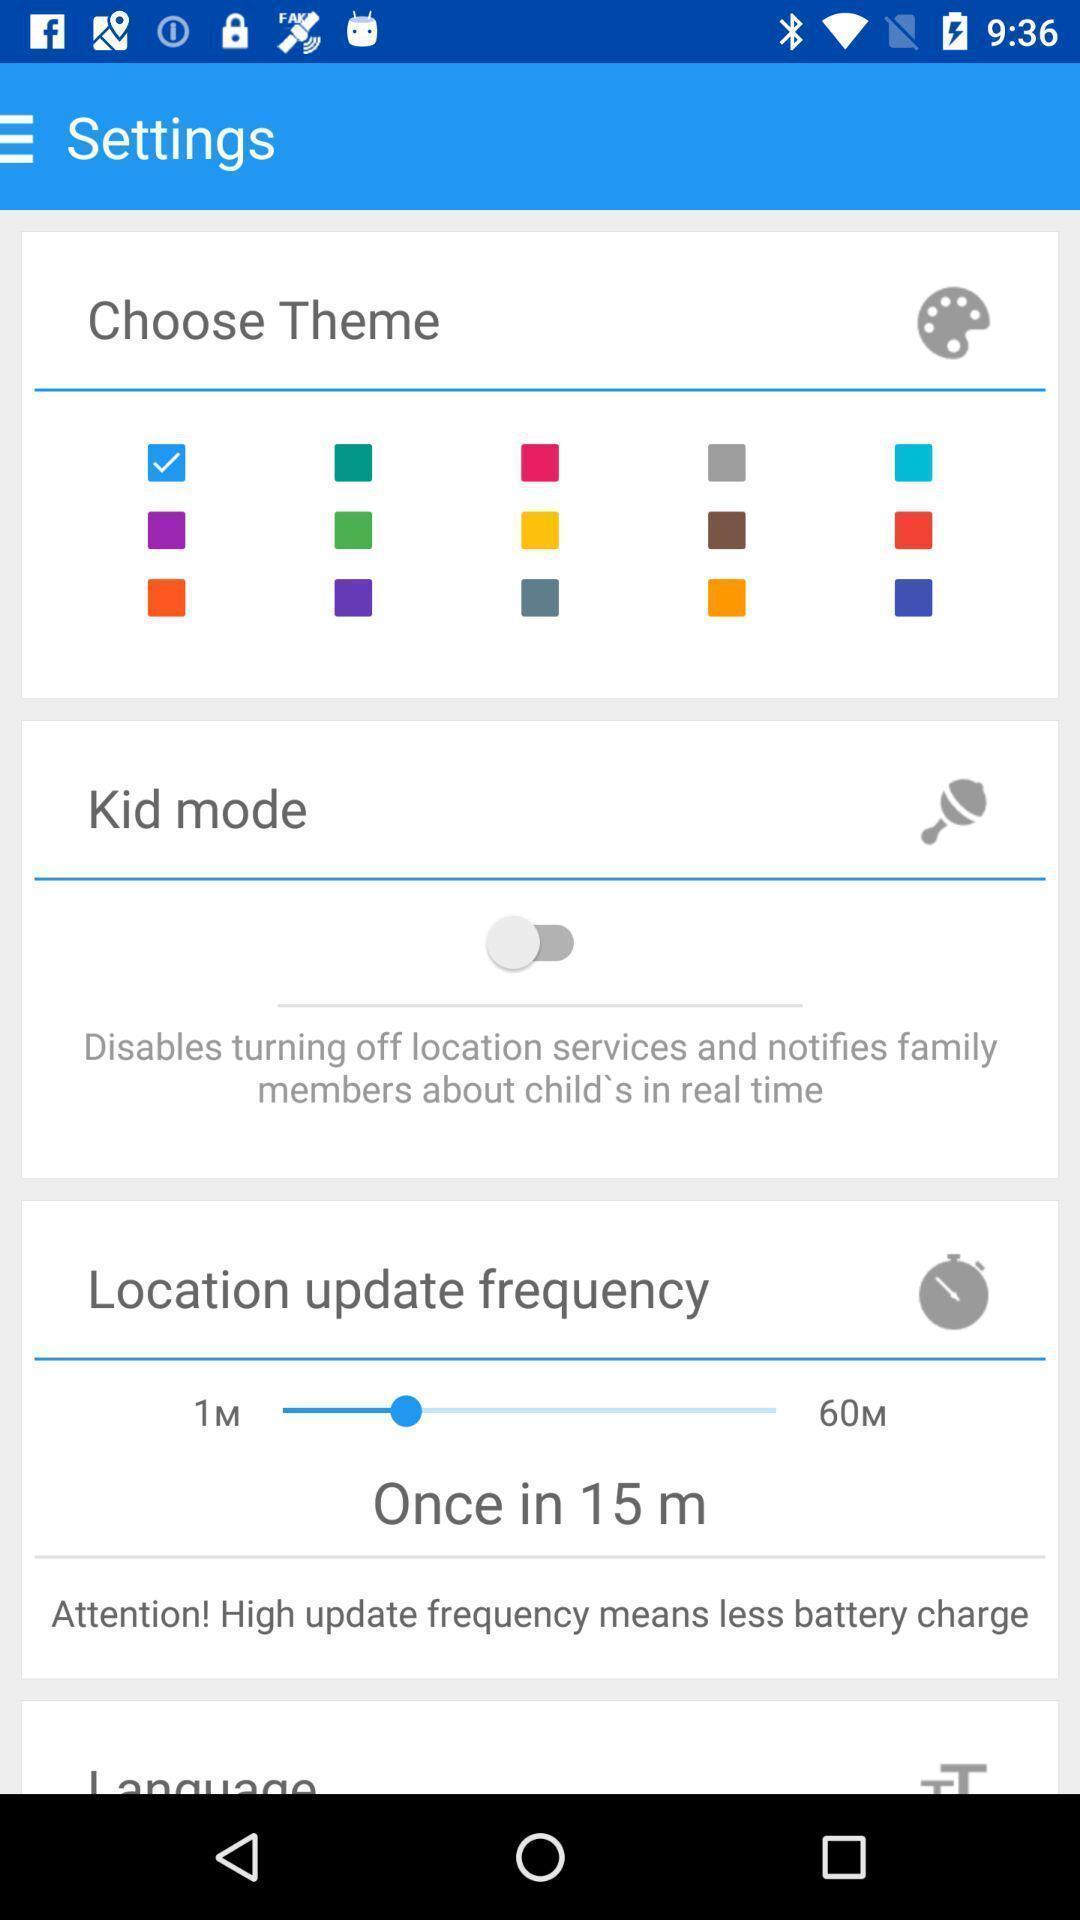Provide a textual representation of this image. Settings page displaying to choose theme and set frequency. 